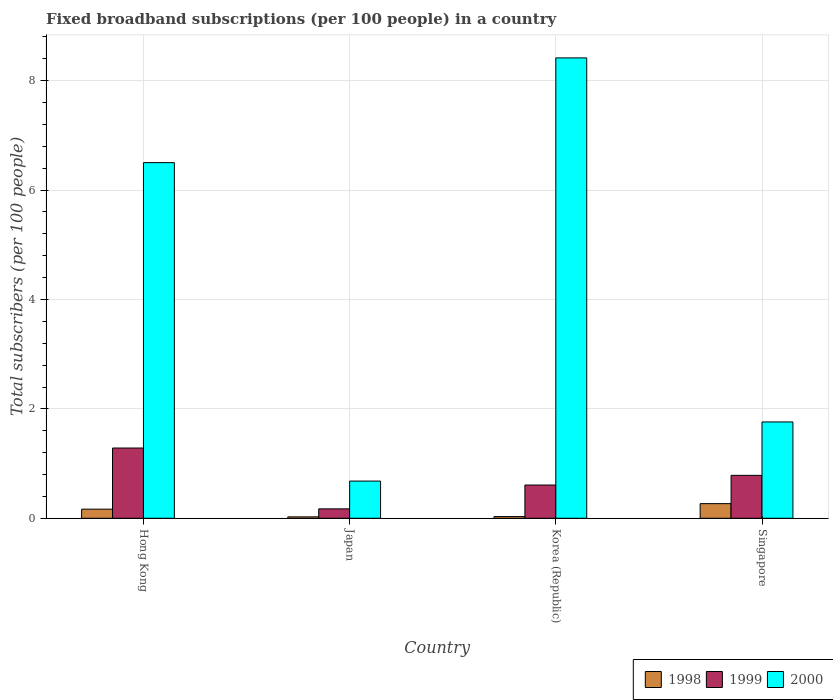How many different coloured bars are there?
Offer a very short reply. 3. How many groups of bars are there?
Give a very brief answer. 4. Are the number of bars on each tick of the X-axis equal?
Offer a very short reply. Yes. What is the label of the 4th group of bars from the left?
Provide a succinct answer. Singapore. In how many cases, is the number of bars for a given country not equal to the number of legend labels?
Keep it short and to the point. 0. What is the number of broadband subscriptions in 2000 in Korea (Republic)?
Your response must be concise. 8.42. Across all countries, what is the maximum number of broadband subscriptions in 2000?
Your response must be concise. 8.42. Across all countries, what is the minimum number of broadband subscriptions in 2000?
Keep it short and to the point. 0.68. In which country was the number of broadband subscriptions in 1999 maximum?
Give a very brief answer. Hong Kong. What is the total number of broadband subscriptions in 1999 in the graph?
Keep it short and to the point. 2.85. What is the difference between the number of broadband subscriptions in 1998 in Hong Kong and that in Japan?
Provide a succinct answer. 0.14. What is the difference between the number of broadband subscriptions in 1998 in Singapore and the number of broadband subscriptions in 2000 in Korea (Republic)?
Keep it short and to the point. -8.15. What is the average number of broadband subscriptions in 2000 per country?
Keep it short and to the point. 4.34. What is the difference between the number of broadband subscriptions of/in 1998 and number of broadband subscriptions of/in 1999 in Singapore?
Your answer should be very brief. -0.52. In how many countries, is the number of broadband subscriptions in 2000 greater than 1.6?
Provide a succinct answer. 3. What is the ratio of the number of broadband subscriptions in 1998 in Korea (Republic) to that in Singapore?
Provide a succinct answer. 0.11. Is the number of broadband subscriptions in 1999 in Hong Kong less than that in Japan?
Your response must be concise. No. What is the difference between the highest and the second highest number of broadband subscriptions in 1998?
Your answer should be compact. 0.1. What is the difference between the highest and the lowest number of broadband subscriptions in 1998?
Provide a short and direct response. 0.24. Is the sum of the number of broadband subscriptions in 1999 in Korea (Republic) and Singapore greater than the maximum number of broadband subscriptions in 2000 across all countries?
Ensure brevity in your answer.  No. What is the difference between two consecutive major ticks on the Y-axis?
Give a very brief answer. 2. Where does the legend appear in the graph?
Offer a terse response. Bottom right. How many legend labels are there?
Ensure brevity in your answer.  3. How are the legend labels stacked?
Provide a short and direct response. Horizontal. What is the title of the graph?
Your answer should be compact. Fixed broadband subscriptions (per 100 people) in a country. Does "2004" appear as one of the legend labels in the graph?
Provide a succinct answer. No. What is the label or title of the X-axis?
Give a very brief answer. Country. What is the label or title of the Y-axis?
Make the answer very short. Total subscribers (per 100 people). What is the Total subscribers (per 100 people) in 1998 in Hong Kong?
Give a very brief answer. 0.17. What is the Total subscribers (per 100 people) in 1999 in Hong Kong?
Give a very brief answer. 1.28. What is the Total subscribers (per 100 people) of 2000 in Hong Kong?
Give a very brief answer. 6.5. What is the Total subscribers (per 100 people) of 1998 in Japan?
Offer a very short reply. 0.03. What is the Total subscribers (per 100 people) of 1999 in Japan?
Offer a very short reply. 0.17. What is the Total subscribers (per 100 people) of 2000 in Japan?
Your response must be concise. 0.68. What is the Total subscribers (per 100 people) in 1998 in Korea (Republic)?
Make the answer very short. 0.03. What is the Total subscribers (per 100 people) of 1999 in Korea (Republic)?
Make the answer very short. 0.61. What is the Total subscribers (per 100 people) in 2000 in Korea (Republic)?
Make the answer very short. 8.42. What is the Total subscribers (per 100 people) of 1998 in Singapore?
Give a very brief answer. 0.27. What is the Total subscribers (per 100 people) in 1999 in Singapore?
Make the answer very short. 0.78. What is the Total subscribers (per 100 people) of 2000 in Singapore?
Provide a succinct answer. 1.76. Across all countries, what is the maximum Total subscribers (per 100 people) in 1998?
Make the answer very short. 0.27. Across all countries, what is the maximum Total subscribers (per 100 people) in 1999?
Provide a succinct answer. 1.28. Across all countries, what is the maximum Total subscribers (per 100 people) in 2000?
Your answer should be very brief. 8.42. Across all countries, what is the minimum Total subscribers (per 100 people) of 1998?
Your response must be concise. 0.03. Across all countries, what is the minimum Total subscribers (per 100 people) in 1999?
Offer a terse response. 0.17. Across all countries, what is the minimum Total subscribers (per 100 people) of 2000?
Make the answer very short. 0.68. What is the total Total subscribers (per 100 people) of 1998 in the graph?
Give a very brief answer. 0.49. What is the total Total subscribers (per 100 people) of 1999 in the graph?
Your answer should be very brief. 2.85. What is the total Total subscribers (per 100 people) of 2000 in the graph?
Keep it short and to the point. 17.36. What is the difference between the Total subscribers (per 100 people) in 1998 in Hong Kong and that in Japan?
Offer a terse response. 0.14. What is the difference between the Total subscribers (per 100 people) of 1999 in Hong Kong and that in Japan?
Provide a short and direct response. 1.11. What is the difference between the Total subscribers (per 100 people) of 2000 in Hong Kong and that in Japan?
Your answer should be compact. 5.82. What is the difference between the Total subscribers (per 100 people) of 1998 in Hong Kong and that in Korea (Republic)?
Provide a succinct answer. 0.14. What is the difference between the Total subscribers (per 100 people) in 1999 in Hong Kong and that in Korea (Republic)?
Your response must be concise. 0.68. What is the difference between the Total subscribers (per 100 people) of 2000 in Hong Kong and that in Korea (Republic)?
Your answer should be compact. -1.91. What is the difference between the Total subscribers (per 100 people) in 1998 in Hong Kong and that in Singapore?
Your answer should be very brief. -0.1. What is the difference between the Total subscribers (per 100 people) in 1999 in Hong Kong and that in Singapore?
Give a very brief answer. 0.5. What is the difference between the Total subscribers (per 100 people) in 2000 in Hong Kong and that in Singapore?
Give a very brief answer. 4.74. What is the difference between the Total subscribers (per 100 people) in 1998 in Japan and that in Korea (Republic)?
Provide a succinct answer. -0.01. What is the difference between the Total subscribers (per 100 people) of 1999 in Japan and that in Korea (Republic)?
Offer a terse response. -0.44. What is the difference between the Total subscribers (per 100 people) of 2000 in Japan and that in Korea (Republic)?
Your answer should be very brief. -7.74. What is the difference between the Total subscribers (per 100 people) of 1998 in Japan and that in Singapore?
Offer a terse response. -0.24. What is the difference between the Total subscribers (per 100 people) of 1999 in Japan and that in Singapore?
Your answer should be very brief. -0.61. What is the difference between the Total subscribers (per 100 people) in 2000 in Japan and that in Singapore?
Make the answer very short. -1.08. What is the difference between the Total subscribers (per 100 people) in 1998 in Korea (Republic) and that in Singapore?
Offer a very short reply. -0.24. What is the difference between the Total subscribers (per 100 people) of 1999 in Korea (Republic) and that in Singapore?
Give a very brief answer. -0.18. What is the difference between the Total subscribers (per 100 people) of 2000 in Korea (Republic) and that in Singapore?
Offer a terse response. 6.66. What is the difference between the Total subscribers (per 100 people) in 1998 in Hong Kong and the Total subscribers (per 100 people) in 1999 in Japan?
Provide a succinct answer. -0.01. What is the difference between the Total subscribers (per 100 people) in 1998 in Hong Kong and the Total subscribers (per 100 people) in 2000 in Japan?
Your answer should be very brief. -0.51. What is the difference between the Total subscribers (per 100 people) in 1999 in Hong Kong and the Total subscribers (per 100 people) in 2000 in Japan?
Give a very brief answer. 0.6. What is the difference between the Total subscribers (per 100 people) in 1998 in Hong Kong and the Total subscribers (per 100 people) in 1999 in Korea (Republic)?
Your answer should be compact. -0.44. What is the difference between the Total subscribers (per 100 people) in 1998 in Hong Kong and the Total subscribers (per 100 people) in 2000 in Korea (Republic)?
Keep it short and to the point. -8.25. What is the difference between the Total subscribers (per 100 people) of 1999 in Hong Kong and the Total subscribers (per 100 people) of 2000 in Korea (Republic)?
Give a very brief answer. -7.13. What is the difference between the Total subscribers (per 100 people) in 1998 in Hong Kong and the Total subscribers (per 100 people) in 1999 in Singapore?
Your answer should be very brief. -0.62. What is the difference between the Total subscribers (per 100 people) in 1998 in Hong Kong and the Total subscribers (per 100 people) in 2000 in Singapore?
Keep it short and to the point. -1.59. What is the difference between the Total subscribers (per 100 people) of 1999 in Hong Kong and the Total subscribers (per 100 people) of 2000 in Singapore?
Provide a succinct answer. -0.48. What is the difference between the Total subscribers (per 100 people) of 1998 in Japan and the Total subscribers (per 100 people) of 1999 in Korea (Republic)?
Provide a short and direct response. -0.58. What is the difference between the Total subscribers (per 100 people) of 1998 in Japan and the Total subscribers (per 100 people) of 2000 in Korea (Republic)?
Keep it short and to the point. -8.39. What is the difference between the Total subscribers (per 100 people) in 1999 in Japan and the Total subscribers (per 100 people) in 2000 in Korea (Republic)?
Your answer should be compact. -8.25. What is the difference between the Total subscribers (per 100 people) in 1998 in Japan and the Total subscribers (per 100 people) in 1999 in Singapore?
Keep it short and to the point. -0.76. What is the difference between the Total subscribers (per 100 people) of 1998 in Japan and the Total subscribers (per 100 people) of 2000 in Singapore?
Your answer should be very brief. -1.74. What is the difference between the Total subscribers (per 100 people) of 1999 in Japan and the Total subscribers (per 100 people) of 2000 in Singapore?
Ensure brevity in your answer.  -1.59. What is the difference between the Total subscribers (per 100 people) in 1998 in Korea (Republic) and the Total subscribers (per 100 people) in 1999 in Singapore?
Offer a terse response. -0.75. What is the difference between the Total subscribers (per 100 people) in 1998 in Korea (Republic) and the Total subscribers (per 100 people) in 2000 in Singapore?
Provide a short and direct response. -1.73. What is the difference between the Total subscribers (per 100 people) in 1999 in Korea (Republic) and the Total subscribers (per 100 people) in 2000 in Singapore?
Your response must be concise. -1.15. What is the average Total subscribers (per 100 people) of 1998 per country?
Give a very brief answer. 0.12. What is the average Total subscribers (per 100 people) of 1999 per country?
Offer a very short reply. 0.71. What is the average Total subscribers (per 100 people) in 2000 per country?
Offer a terse response. 4.34. What is the difference between the Total subscribers (per 100 people) of 1998 and Total subscribers (per 100 people) of 1999 in Hong Kong?
Give a very brief answer. -1.12. What is the difference between the Total subscribers (per 100 people) in 1998 and Total subscribers (per 100 people) in 2000 in Hong Kong?
Provide a succinct answer. -6.34. What is the difference between the Total subscribers (per 100 people) of 1999 and Total subscribers (per 100 people) of 2000 in Hong Kong?
Ensure brevity in your answer.  -5.22. What is the difference between the Total subscribers (per 100 people) in 1998 and Total subscribers (per 100 people) in 1999 in Japan?
Ensure brevity in your answer.  -0.15. What is the difference between the Total subscribers (per 100 people) in 1998 and Total subscribers (per 100 people) in 2000 in Japan?
Provide a short and direct response. -0.65. What is the difference between the Total subscribers (per 100 people) of 1999 and Total subscribers (per 100 people) of 2000 in Japan?
Make the answer very short. -0.51. What is the difference between the Total subscribers (per 100 people) of 1998 and Total subscribers (per 100 people) of 1999 in Korea (Republic)?
Your answer should be compact. -0.58. What is the difference between the Total subscribers (per 100 people) of 1998 and Total subscribers (per 100 people) of 2000 in Korea (Republic)?
Provide a succinct answer. -8.39. What is the difference between the Total subscribers (per 100 people) of 1999 and Total subscribers (per 100 people) of 2000 in Korea (Republic)?
Give a very brief answer. -7.81. What is the difference between the Total subscribers (per 100 people) of 1998 and Total subscribers (per 100 people) of 1999 in Singapore?
Offer a very short reply. -0.52. What is the difference between the Total subscribers (per 100 people) of 1998 and Total subscribers (per 100 people) of 2000 in Singapore?
Your response must be concise. -1.49. What is the difference between the Total subscribers (per 100 people) of 1999 and Total subscribers (per 100 people) of 2000 in Singapore?
Provide a succinct answer. -0.98. What is the ratio of the Total subscribers (per 100 people) in 1998 in Hong Kong to that in Japan?
Offer a very short reply. 6.53. What is the ratio of the Total subscribers (per 100 people) of 1999 in Hong Kong to that in Japan?
Make the answer very short. 7.46. What is the ratio of the Total subscribers (per 100 people) in 2000 in Hong Kong to that in Japan?
Offer a very short reply. 9.56. What is the ratio of the Total subscribers (per 100 people) of 1998 in Hong Kong to that in Korea (Republic)?
Offer a terse response. 5.42. What is the ratio of the Total subscribers (per 100 people) in 1999 in Hong Kong to that in Korea (Republic)?
Ensure brevity in your answer.  2.11. What is the ratio of the Total subscribers (per 100 people) in 2000 in Hong Kong to that in Korea (Republic)?
Your answer should be compact. 0.77. What is the ratio of the Total subscribers (per 100 people) of 1998 in Hong Kong to that in Singapore?
Make the answer very short. 0.62. What is the ratio of the Total subscribers (per 100 people) in 1999 in Hong Kong to that in Singapore?
Keep it short and to the point. 1.64. What is the ratio of the Total subscribers (per 100 people) in 2000 in Hong Kong to that in Singapore?
Your answer should be very brief. 3.69. What is the ratio of the Total subscribers (per 100 people) of 1998 in Japan to that in Korea (Republic)?
Provide a succinct answer. 0.83. What is the ratio of the Total subscribers (per 100 people) in 1999 in Japan to that in Korea (Republic)?
Your answer should be compact. 0.28. What is the ratio of the Total subscribers (per 100 people) in 2000 in Japan to that in Korea (Republic)?
Offer a terse response. 0.08. What is the ratio of the Total subscribers (per 100 people) of 1998 in Japan to that in Singapore?
Ensure brevity in your answer.  0.1. What is the ratio of the Total subscribers (per 100 people) in 1999 in Japan to that in Singapore?
Your answer should be compact. 0.22. What is the ratio of the Total subscribers (per 100 people) in 2000 in Japan to that in Singapore?
Your response must be concise. 0.39. What is the ratio of the Total subscribers (per 100 people) in 1998 in Korea (Republic) to that in Singapore?
Offer a terse response. 0.12. What is the ratio of the Total subscribers (per 100 people) in 1999 in Korea (Republic) to that in Singapore?
Your answer should be very brief. 0.77. What is the ratio of the Total subscribers (per 100 people) in 2000 in Korea (Republic) to that in Singapore?
Offer a terse response. 4.78. What is the difference between the highest and the second highest Total subscribers (per 100 people) in 1998?
Keep it short and to the point. 0.1. What is the difference between the highest and the second highest Total subscribers (per 100 people) of 1999?
Offer a terse response. 0.5. What is the difference between the highest and the second highest Total subscribers (per 100 people) in 2000?
Keep it short and to the point. 1.91. What is the difference between the highest and the lowest Total subscribers (per 100 people) in 1998?
Your answer should be very brief. 0.24. What is the difference between the highest and the lowest Total subscribers (per 100 people) of 1999?
Offer a terse response. 1.11. What is the difference between the highest and the lowest Total subscribers (per 100 people) in 2000?
Give a very brief answer. 7.74. 